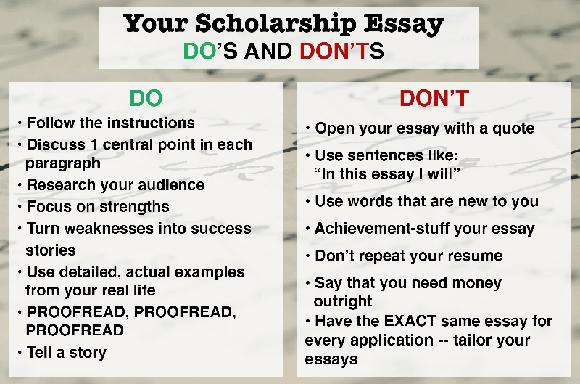What are some of the DON'Ts mentioned for writing a scholarship essay? When crafting your scholarship essay, avoid starting with a quotation, as it may seem unoriginal or overused. Steer clear of formulaic introductions like 'In this essay, I will...' which can appear predictable. Refrain from using unfamiliar vocabulary to ensure clarity and precision in your message. Avoid 'achievement-stuffing' your essay by selectively sharing experiences that align with the scholarship's objectives. It's also crucial not to merely repeat what's already in your resume; instead, add new insights and depth. Don’t outright declare your financial needs; focus on why you are a worthy candidate. Tailor each essay to the specific scholarship application, highlighting relevant aspects of your experiences and aspirations. 